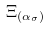<formula> <loc_0><loc_0><loc_500><loc_500>\Xi _ { ( \alpha _ { \sigma } ) }</formula> 